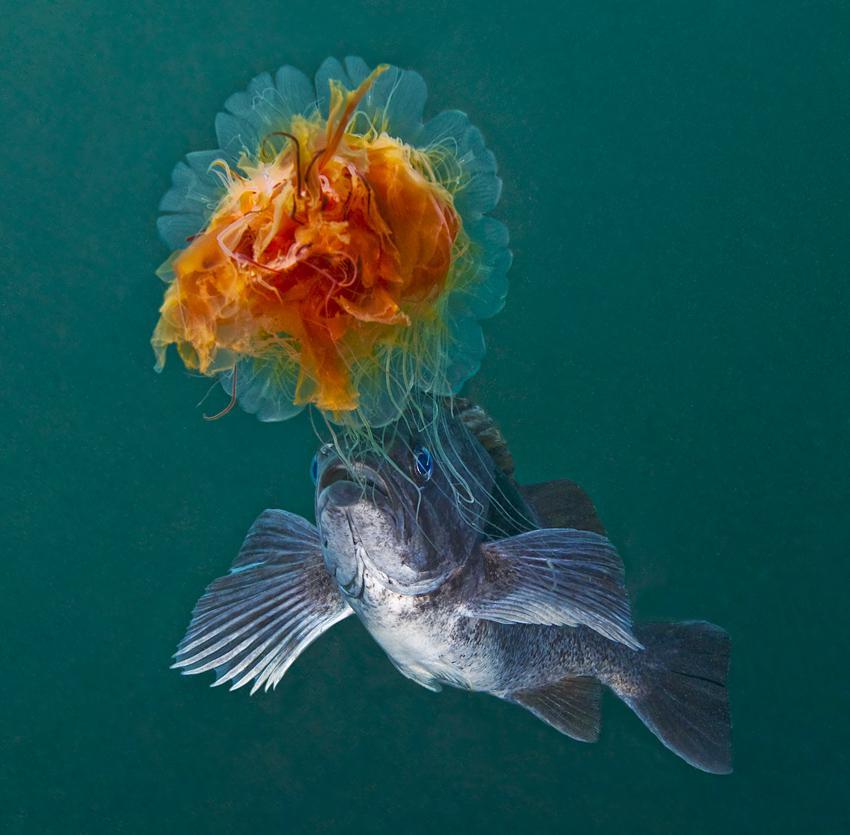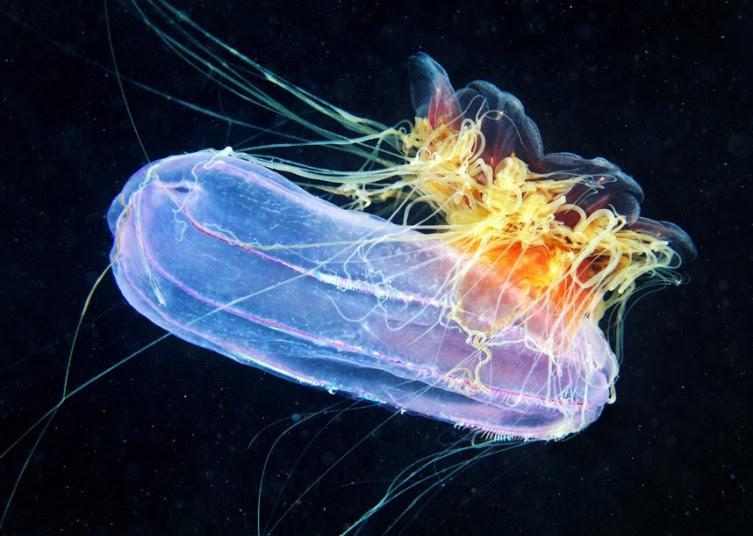The first image is the image on the left, the second image is the image on the right. Considering the images on both sides, is "An image shows a mushroom-shaped purplish jellyfish with tentacles reaching in all directions and enveloping at least one other creature." valid? Answer yes or no. No. The first image is the image on the left, the second image is the image on the right. Analyze the images presented: Is the assertion "in at least one image there is at least two jellyfish with at least one that is both red, black and fire colored." valid? Answer yes or no. No. 